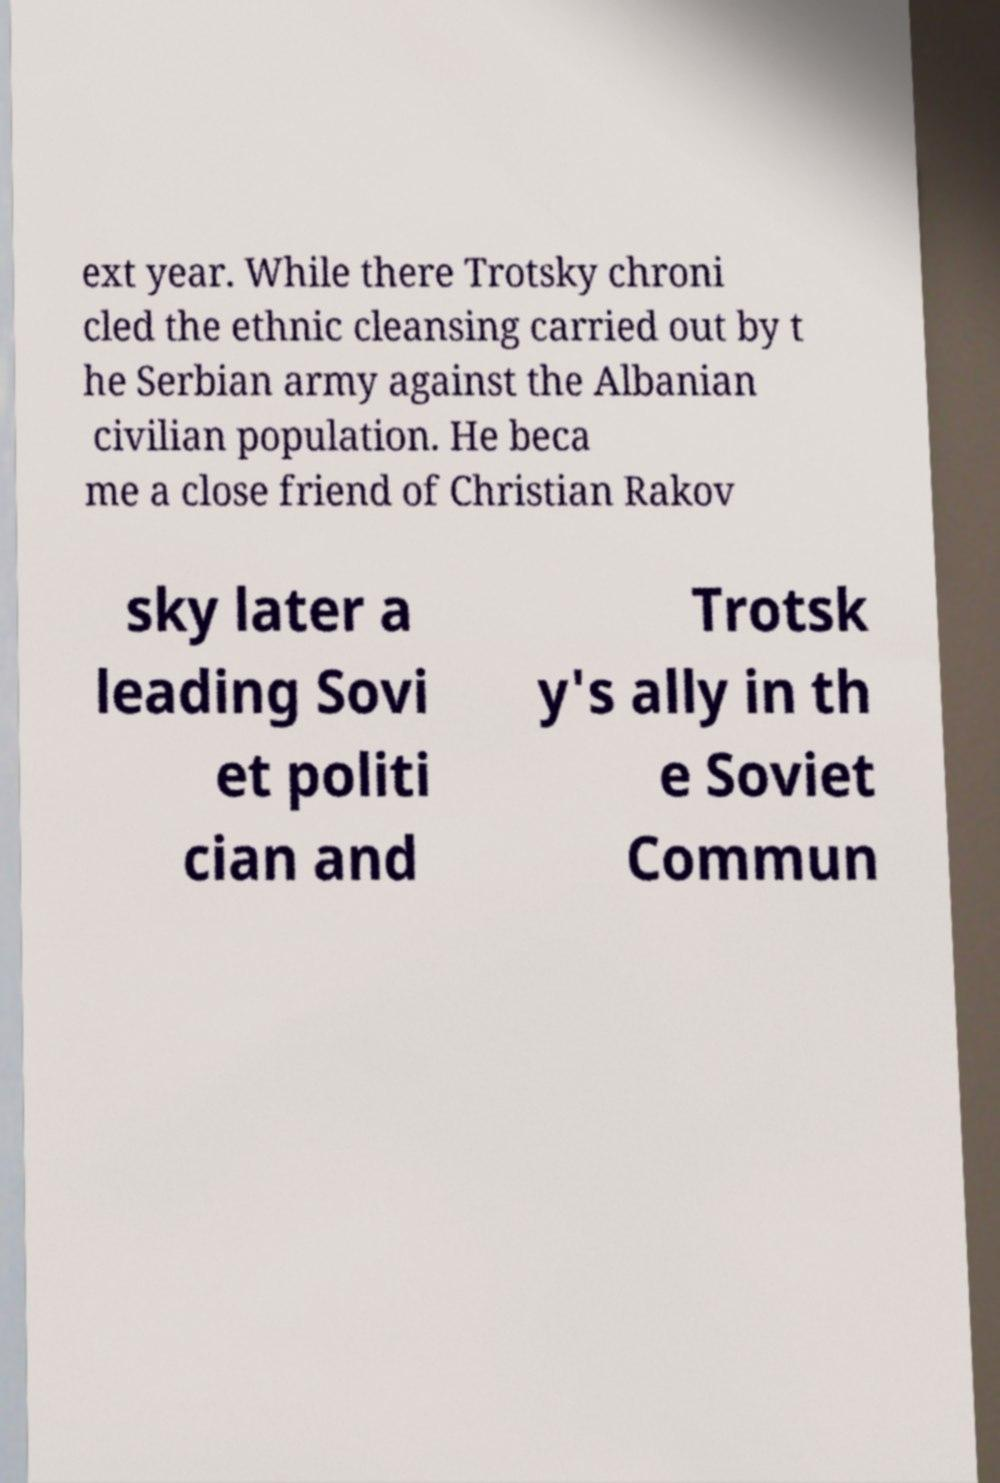Please identify and transcribe the text found in this image. ext year. While there Trotsky chroni cled the ethnic cleansing carried out by t he Serbian army against the Albanian civilian population. He beca me a close friend of Christian Rakov sky later a leading Sovi et politi cian and Trotsk y's ally in th e Soviet Commun 